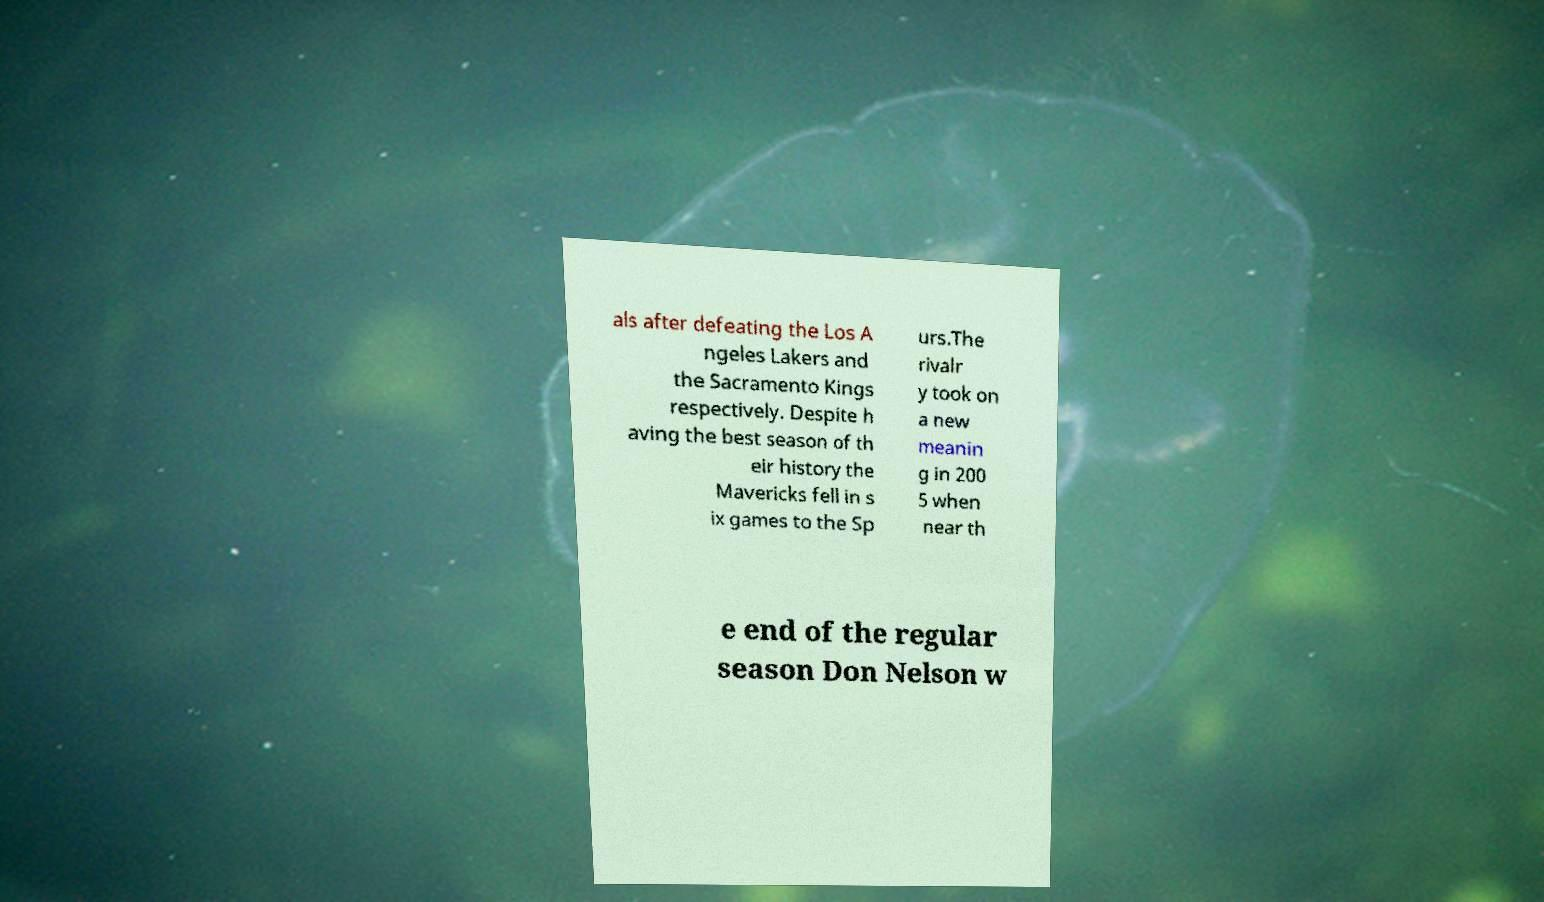For documentation purposes, I need the text within this image transcribed. Could you provide that? als after defeating the Los A ngeles Lakers and the Sacramento Kings respectively. Despite h aving the best season of th eir history the Mavericks fell in s ix games to the Sp urs.The rivalr y took on a new meanin g in 200 5 when near th e end of the regular season Don Nelson w 